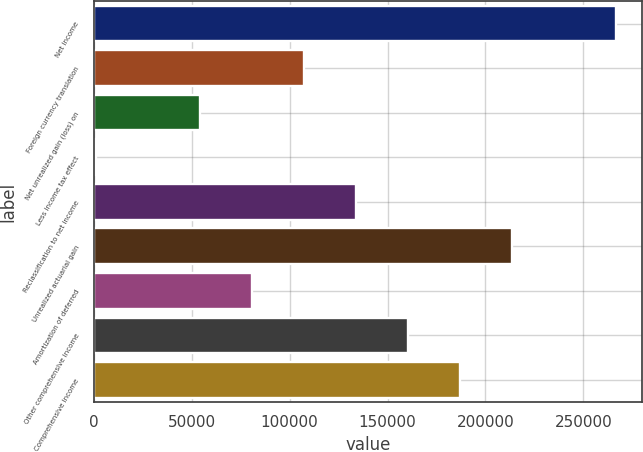Convert chart. <chart><loc_0><loc_0><loc_500><loc_500><bar_chart><fcel>Net income<fcel>Foreign currency translation<fcel>Net unrealized gain (loss) on<fcel>Less income tax effect<fcel>Reclassification to net income<fcel>Unrealized actuarial gain<fcel>Amortization of deferred<fcel>Other comprehensive income<fcel>Comprehensive income<nl><fcel>266688<fcel>107429<fcel>54343.2<fcel>1257<fcel>133972<fcel>213602<fcel>80886.3<fcel>160516<fcel>187059<nl></chart> 